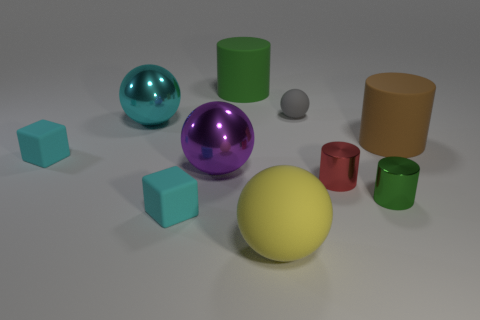Subtract all brown cylinders. How many cylinders are left? 3 Subtract 3 balls. How many balls are left? 1 Subtract all green cylinders. How many cylinders are left? 2 Subtract all gray balls. Subtract all purple cubes. How many balls are left? 3 Subtract 0 green spheres. How many objects are left? 10 Subtract all spheres. How many objects are left? 6 Subtract all brown cylinders. How many cyan spheres are left? 1 Subtract all small blocks. Subtract all tiny rubber blocks. How many objects are left? 6 Add 3 cyan matte cubes. How many cyan matte cubes are left? 5 Add 8 tiny brown cylinders. How many tiny brown cylinders exist? 8 